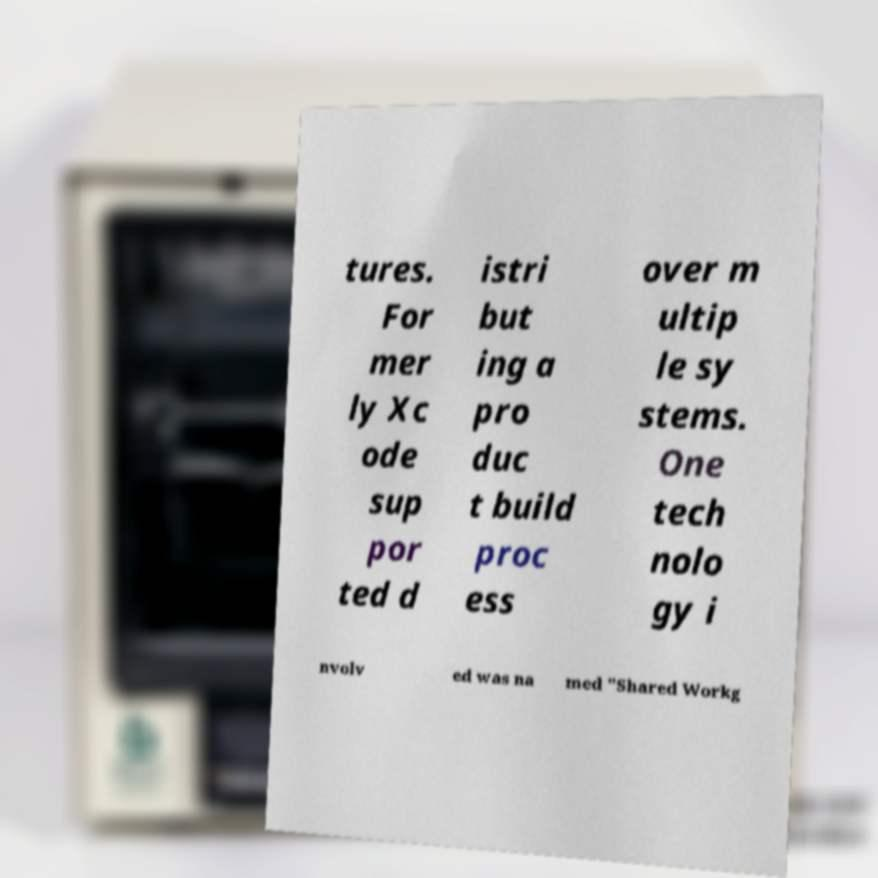Could you extract and type out the text from this image? tures. For mer ly Xc ode sup por ted d istri but ing a pro duc t build proc ess over m ultip le sy stems. One tech nolo gy i nvolv ed was na med "Shared Workg 